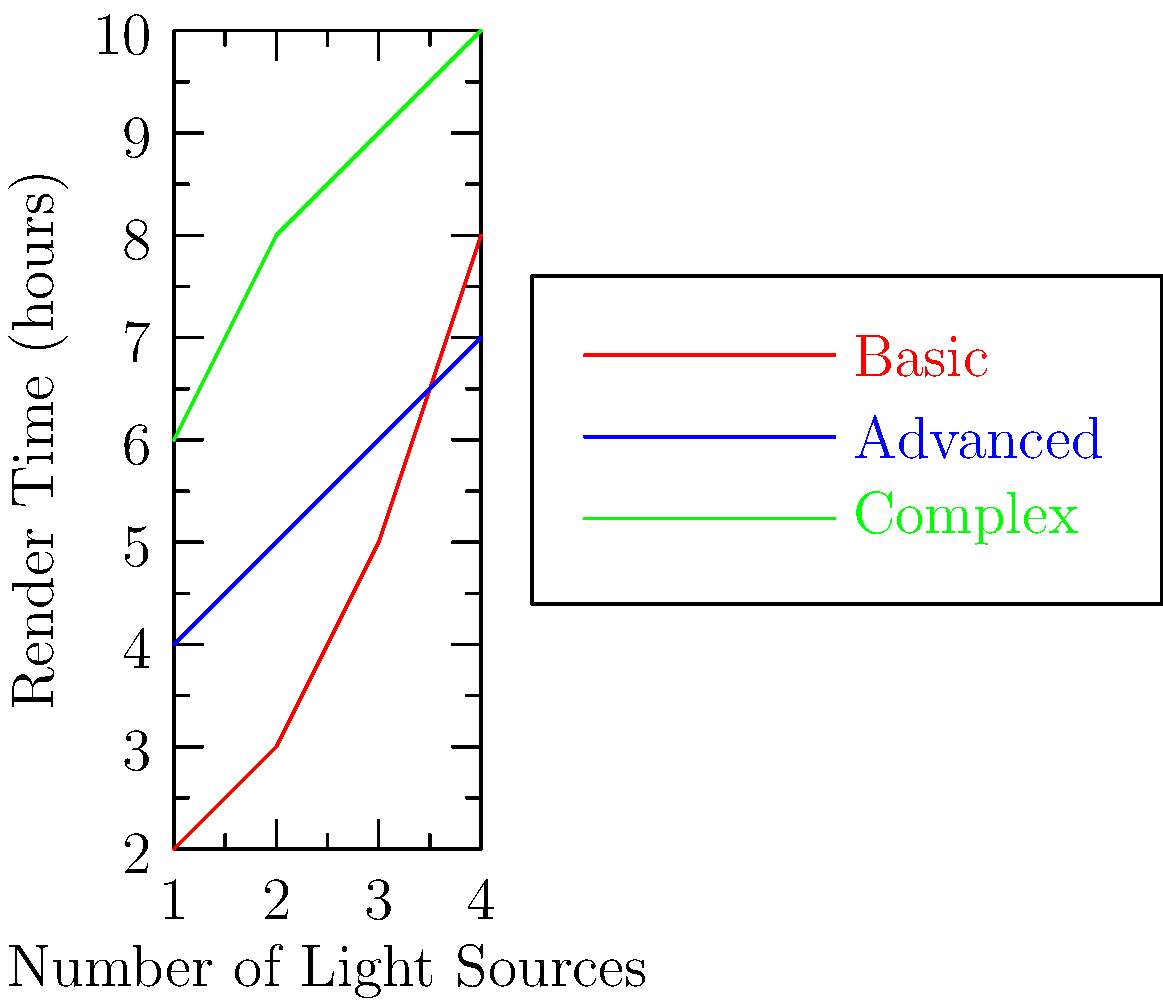Based on the graph showing render times for different lighting setups, which setup demonstrates the most efficient scaling as the number of light sources increases? To determine which lighting setup scales most efficiently, we need to analyze the rate of increase in render time as the number of light sources increases:

1. Basic setup (red line):
   - Starts at 2 hours for 1 light source
   - Ends at 8 hours for 4 light sources
   - Total increase: 6 hours
   - Rate of increase: steep and non-linear

2. Advanced setup (blue line):
   - Starts at 4 hours for 1 light source
   - Ends at 7 hours for 4 light sources
   - Total increase: 3 hours
   - Rate of increase: gradual and nearly linear

3. Complex setup (green line):
   - Starts at 6 hours for 1 light source
   - Ends at 10 hours for 4 light sources
   - Total increase: 4 hours
   - Rate of increase: moderate and slightly curved

The Advanced setup (blue line) shows the smallest total increase in render time (3 hours) and the most linear growth. This indicates that it scales most efficiently as the number of light sources increases.
Answer: Advanced setup 